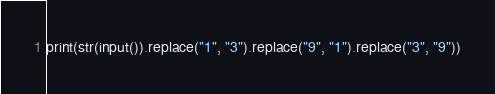Convert code to text. <code><loc_0><loc_0><loc_500><loc_500><_Python_>print(str(input()).replace("1", "3").replace("9", "1").replace("3", "9"))</code> 